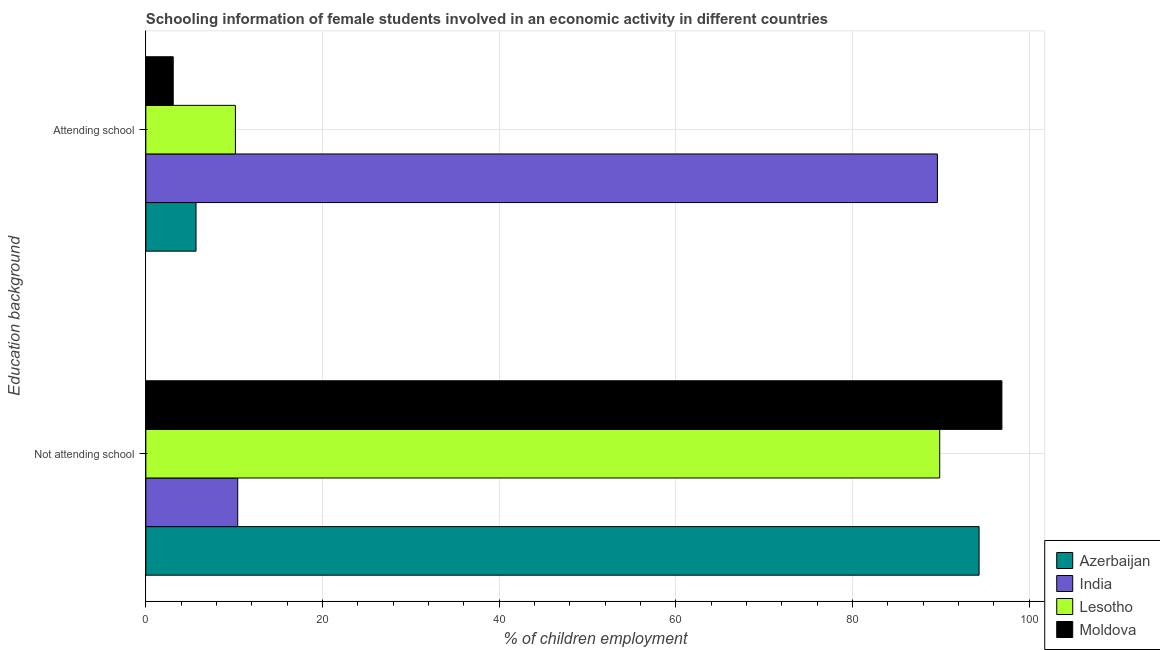How many different coloured bars are there?
Ensure brevity in your answer.  4. How many groups of bars are there?
Your answer should be very brief. 2. Are the number of bars per tick equal to the number of legend labels?
Provide a succinct answer. Yes. What is the label of the 1st group of bars from the top?
Give a very brief answer. Attending school. Across all countries, what is the maximum percentage of employed females who are not attending school?
Your answer should be very brief. 96.9. Across all countries, what is the minimum percentage of employed females who are attending school?
Offer a terse response. 3.1. In which country was the percentage of employed females who are attending school maximum?
Keep it short and to the point. India. In which country was the percentage of employed females who are not attending school minimum?
Provide a short and direct response. India. What is the total percentage of employed females who are attending school in the graph?
Offer a terse response. 108.52. What is the difference between the percentage of employed females who are not attending school in Moldova and that in Azerbaijan?
Offer a terse response. 2.58. What is the difference between the percentage of employed females who are attending school in Azerbaijan and the percentage of employed females who are not attending school in India?
Offer a terse response. -4.72. What is the average percentage of employed females who are not attending school per country?
Provide a succinct answer. 72.87. What is the difference between the percentage of employed females who are not attending school and percentage of employed females who are attending school in Azerbaijan?
Give a very brief answer. 88.64. What is the ratio of the percentage of employed females who are attending school in Azerbaijan to that in Lesotho?
Provide a succinct answer. 0.56. Is the percentage of employed females who are attending school in Azerbaijan less than that in Lesotho?
Your answer should be compact. Yes. What does the 3rd bar from the top in Attending school represents?
Offer a very short reply. India. What does the 1st bar from the bottom in Attending school represents?
Provide a succinct answer. Azerbaijan. How many bars are there?
Make the answer very short. 8. Are all the bars in the graph horizontal?
Provide a short and direct response. Yes. How many countries are there in the graph?
Offer a very short reply. 4. What is the difference between two consecutive major ticks on the X-axis?
Keep it short and to the point. 20. Are the values on the major ticks of X-axis written in scientific E-notation?
Your response must be concise. No. Does the graph contain any zero values?
Ensure brevity in your answer.  No. Does the graph contain grids?
Your response must be concise. Yes. What is the title of the graph?
Make the answer very short. Schooling information of female students involved in an economic activity in different countries. Does "Sweden" appear as one of the legend labels in the graph?
Provide a succinct answer. No. What is the label or title of the X-axis?
Offer a terse response. % of children employment. What is the label or title of the Y-axis?
Give a very brief answer. Education background. What is the % of children employment in Azerbaijan in Not attending school?
Your answer should be very brief. 94.32. What is the % of children employment in India in Not attending school?
Offer a very short reply. 10.4. What is the % of children employment of Lesotho in Not attending school?
Your response must be concise. 89.86. What is the % of children employment in Moldova in Not attending school?
Make the answer very short. 96.9. What is the % of children employment in Azerbaijan in Attending school?
Give a very brief answer. 5.68. What is the % of children employment in India in Attending school?
Your response must be concise. 89.6. What is the % of children employment of Lesotho in Attending school?
Provide a succinct answer. 10.14. What is the % of children employment in Moldova in Attending school?
Provide a short and direct response. 3.1. Across all Education background, what is the maximum % of children employment in Azerbaijan?
Your response must be concise. 94.32. Across all Education background, what is the maximum % of children employment in India?
Make the answer very short. 89.6. Across all Education background, what is the maximum % of children employment in Lesotho?
Offer a terse response. 89.86. Across all Education background, what is the maximum % of children employment in Moldova?
Keep it short and to the point. 96.9. Across all Education background, what is the minimum % of children employment in Azerbaijan?
Make the answer very short. 5.68. Across all Education background, what is the minimum % of children employment in India?
Keep it short and to the point. 10.4. Across all Education background, what is the minimum % of children employment of Lesotho?
Give a very brief answer. 10.14. Across all Education background, what is the minimum % of children employment of Moldova?
Your answer should be compact. 3.1. What is the total % of children employment in Azerbaijan in the graph?
Keep it short and to the point. 100. What is the total % of children employment in Moldova in the graph?
Keep it short and to the point. 100. What is the difference between the % of children employment in Azerbaijan in Not attending school and that in Attending school?
Keep it short and to the point. 88.64. What is the difference between the % of children employment in India in Not attending school and that in Attending school?
Offer a terse response. -79.2. What is the difference between the % of children employment of Lesotho in Not attending school and that in Attending school?
Offer a terse response. 79.72. What is the difference between the % of children employment in Moldova in Not attending school and that in Attending school?
Keep it short and to the point. 93.8. What is the difference between the % of children employment of Azerbaijan in Not attending school and the % of children employment of India in Attending school?
Offer a terse response. 4.72. What is the difference between the % of children employment in Azerbaijan in Not attending school and the % of children employment in Lesotho in Attending school?
Keep it short and to the point. 84.18. What is the difference between the % of children employment in Azerbaijan in Not attending school and the % of children employment in Moldova in Attending school?
Give a very brief answer. 91.22. What is the difference between the % of children employment of India in Not attending school and the % of children employment of Lesotho in Attending school?
Give a very brief answer. 0.26. What is the difference between the % of children employment in India in Not attending school and the % of children employment in Moldova in Attending school?
Your response must be concise. 7.3. What is the difference between the % of children employment of Lesotho in Not attending school and the % of children employment of Moldova in Attending school?
Ensure brevity in your answer.  86.76. What is the average % of children employment in Lesotho per Education background?
Make the answer very short. 50. What is the average % of children employment of Moldova per Education background?
Keep it short and to the point. 50. What is the difference between the % of children employment of Azerbaijan and % of children employment of India in Not attending school?
Make the answer very short. 83.92. What is the difference between the % of children employment in Azerbaijan and % of children employment in Lesotho in Not attending school?
Offer a very short reply. 4.46. What is the difference between the % of children employment in Azerbaijan and % of children employment in Moldova in Not attending school?
Make the answer very short. -2.58. What is the difference between the % of children employment in India and % of children employment in Lesotho in Not attending school?
Your answer should be compact. -79.46. What is the difference between the % of children employment of India and % of children employment of Moldova in Not attending school?
Your answer should be compact. -86.5. What is the difference between the % of children employment of Lesotho and % of children employment of Moldova in Not attending school?
Your response must be concise. -7.04. What is the difference between the % of children employment of Azerbaijan and % of children employment of India in Attending school?
Give a very brief answer. -83.92. What is the difference between the % of children employment in Azerbaijan and % of children employment in Lesotho in Attending school?
Offer a terse response. -4.46. What is the difference between the % of children employment in Azerbaijan and % of children employment in Moldova in Attending school?
Your answer should be compact. 2.58. What is the difference between the % of children employment of India and % of children employment of Lesotho in Attending school?
Keep it short and to the point. 79.46. What is the difference between the % of children employment of India and % of children employment of Moldova in Attending school?
Provide a short and direct response. 86.5. What is the difference between the % of children employment in Lesotho and % of children employment in Moldova in Attending school?
Provide a short and direct response. 7.04. What is the ratio of the % of children employment of Azerbaijan in Not attending school to that in Attending school?
Offer a terse response. 16.6. What is the ratio of the % of children employment of India in Not attending school to that in Attending school?
Your response must be concise. 0.12. What is the ratio of the % of children employment in Lesotho in Not attending school to that in Attending school?
Keep it short and to the point. 8.86. What is the ratio of the % of children employment in Moldova in Not attending school to that in Attending school?
Give a very brief answer. 31.26. What is the difference between the highest and the second highest % of children employment in Azerbaijan?
Ensure brevity in your answer.  88.64. What is the difference between the highest and the second highest % of children employment of India?
Offer a very short reply. 79.2. What is the difference between the highest and the second highest % of children employment of Lesotho?
Give a very brief answer. 79.72. What is the difference between the highest and the second highest % of children employment in Moldova?
Offer a very short reply. 93.8. What is the difference between the highest and the lowest % of children employment in Azerbaijan?
Your answer should be compact. 88.64. What is the difference between the highest and the lowest % of children employment of India?
Ensure brevity in your answer.  79.2. What is the difference between the highest and the lowest % of children employment in Lesotho?
Make the answer very short. 79.72. What is the difference between the highest and the lowest % of children employment in Moldova?
Make the answer very short. 93.8. 